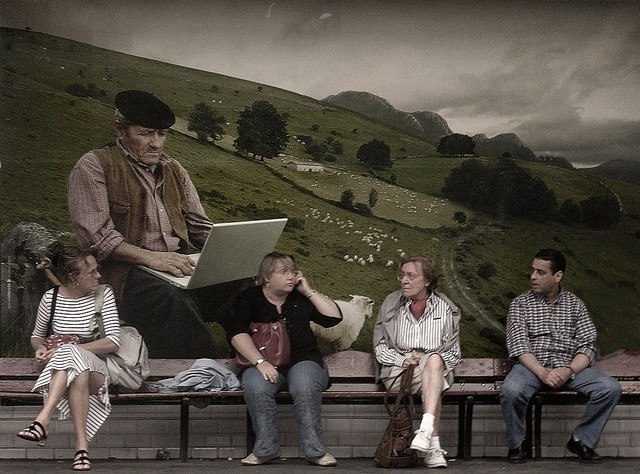Describe the objects in this image and their specific colors. I can see people in black, gray, and maroon tones, people in black, gray, maroon, and darkgray tones, people in black, gray, darkgray, and lightgray tones, people in black, gray, and darkgray tones, and bench in black, gray, and darkgray tones in this image. 